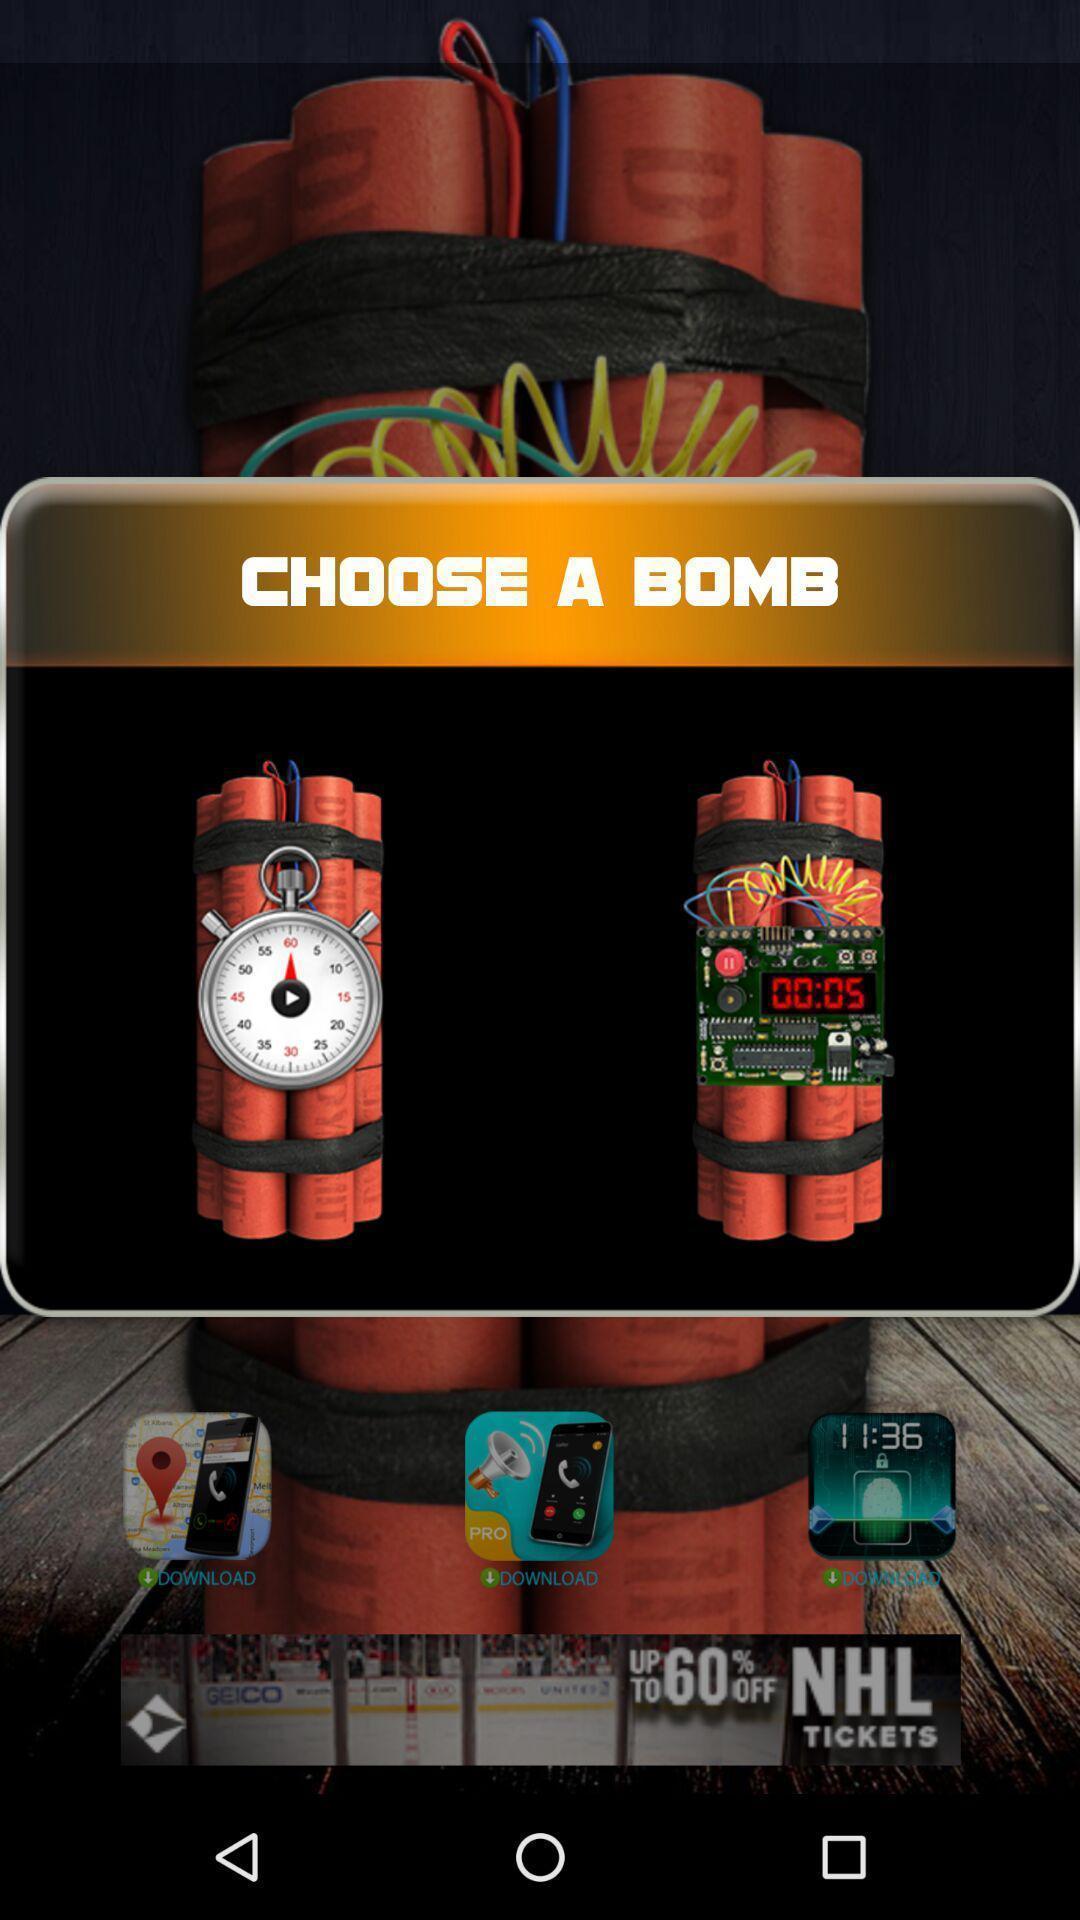What details can you identify in this image? Popup to choose in the gaming app. 